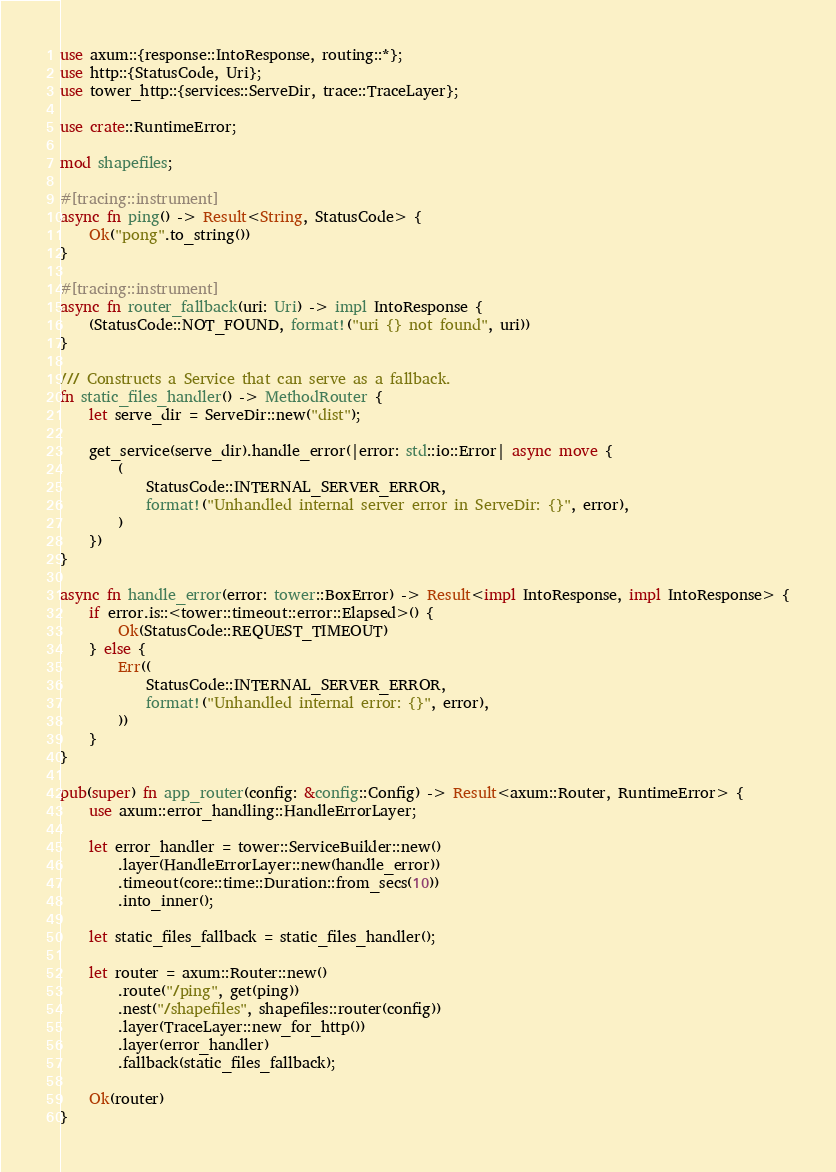<code> <loc_0><loc_0><loc_500><loc_500><_Rust_>use axum::{response::IntoResponse, routing::*};
use http::{StatusCode, Uri};
use tower_http::{services::ServeDir, trace::TraceLayer};

use crate::RuntimeError;

mod shapefiles;

#[tracing::instrument]
async fn ping() -> Result<String, StatusCode> {
	Ok("pong".to_string())
}

#[tracing::instrument]
async fn router_fallback(uri: Uri) -> impl IntoResponse {
	(StatusCode::NOT_FOUND, format!("uri {} not found", uri))
}

/// Constructs a Service that can serve as a fallback.
fn static_files_handler() -> MethodRouter {
	let serve_dir = ServeDir::new("dist");

	get_service(serve_dir).handle_error(|error: std::io::Error| async move {
		(
			StatusCode::INTERNAL_SERVER_ERROR,
			format!("Unhandled internal server error in ServeDir: {}", error),
		)
	})
}

async fn handle_error(error: tower::BoxError) -> Result<impl IntoResponse, impl IntoResponse> {
	if error.is::<tower::timeout::error::Elapsed>() {
		Ok(StatusCode::REQUEST_TIMEOUT)
	} else {
		Err((
			StatusCode::INTERNAL_SERVER_ERROR,
			format!("Unhandled internal error: {}", error),
		))
	}
}

pub(super) fn app_router(config: &config::Config) -> Result<axum::Router, RuntimeError> {
	use axum::error_handling::HandleErrorLayer;

	let error_handler = tower::ServiceBuilder::new()
		.layer(HandleErrorLayer::new(handle_error))
		.timeout(core::time::Duration::from_secs(10))
		.into_inner();

	let static_files_fallback = static_files_handler();

	let router = axum::Router::new()
		.route("/ping", get(ping))
		.nest("/shapefiles", shapefiles::router(config))
		.layer(TraceLayer::new_for_http())
		.layer(error_handler)
		.fallback(static_files_fallback);

	Ok(router)
}
</code> 